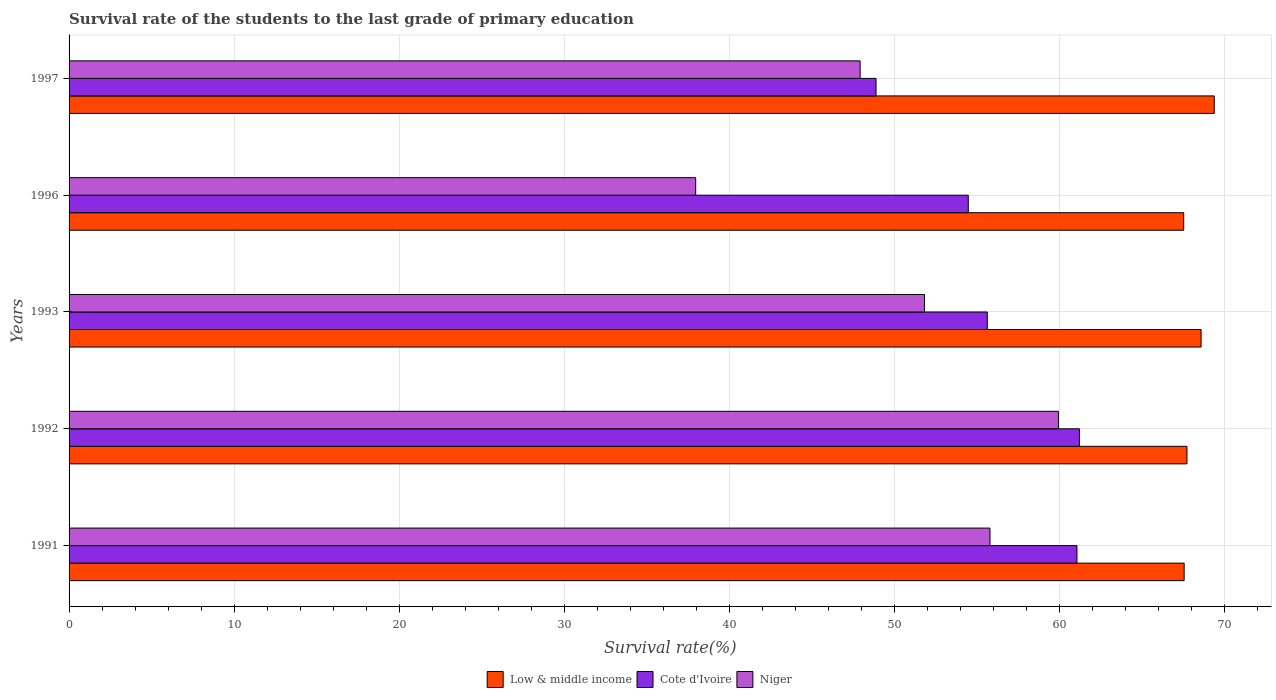How many groups of bars are there?
Ensure brevity in your answer.  5. Are the number of bars per tick equal to the number of legend labels?
Your answer should be very brief. Yes. Are the number of bars on each tick of the Y-axis equal?
Give a very brief answer. Yes. What is the label of the 1st group of bars from the top?
Offer a terse response. 1997. What is the survival rate of the students in Cote d'Ivoire in 1996?
Offer a very short reply. 54.46. Across all years, what is the maximum survival rate of the students in Low & middle income?
Provide a short and direct response. 69.36. Across all years, what is the minimum survival rate of the students in Low & middle income?
Your answer should be very brief. 67.51. In which year was the survival rate of the students in Cote d'Ivoire minimum?
Offer a terse response. 1997. What is the total survival rate of the students in Niger in the graph?
Make the answer very short. 253.36. What is the difference between the survival rate of the students in Low & middle income in 1992 and that in 1997?
Ensure brevity in your answer.  -1.65. What is the difference between the survival rate of the students in Niger in 1992 and the survival rate of the students in Cote d'Ivoire in 1997?
Offer a terse response. 11.05. What is the average survival rate of the students in Cote d'Ivoire per year?
Keep it short and to the point. 56.24. In the year 1997, what is the difference between the survival rate of the students in Niger and survival rate of the students in Low & middle income?
Your response must be concise. -21.45. What is the ratio of the survival rate of the students in Low & middle income in 1992 to that in 1996?
Offer a very short reply. 1. Is the survival rate of the students in Cote d'Ivoire in 1993 less than that in 1996?
Your response must be concise. No. What is the difference between the highest and the second highest survival rate of the students in Niger?
Your answer should be compact. 4.15. What is the difference between the highest and the lowest survival rate of the students in Low & middle income?
Make the answer very short. 1.85. Is the sum of the survival rate of the students in Low & middle income in 1991 and 1992 greater than the maximum survival rate of the students in Cote d'Ivoire across all years?
Your answer should be compact. Yes. What does the 1st bar from the top in 1997 represents?
Keep it short and to the point. Niger. What is the difference between two consecutive major ticks on the X-axis?
Ensure brevity in your answer.  10. Does the graph contain grids?
Offer a very short reply. Yes. What is the title of the graph?
Ensure brevity in your answer.  Survival rate of the students to the last grade of primary education. Does "Ethiopia" appear as one of the legend labels in the graph?
Provide a succinct answer. No. What is the label or title of the X-axis?
Provide a succinct answer. Survival rate(%). What is the Survival rate(%) in Low & middle income in 1991?
Offer a terse response. 67.53. What is the Survival rate(%) of Cote d'Ivoire in 1991?
Your response must be concise. 61.04. What is the Survival rate(%) in Niger in 1991?
Make the answer very short. 55.77. What is the Survival rate(%) in Low & middle income in 1992?
Offer a terse response. 67.7. What is the Survival rate(%) of Cote d'Ivoire in 1992?
Provide a succinct answer. 61.19. What is the Survival rate(%) in Niger in 1992?
Offer a terse response. 59.92. What is the Survival rate(%) in Low & middle income in 1993?
Your response must be concise. 68.56. What is the Survival rate(%) in Cote d'Ivoire in 1993?
Ensure brevity in your answer.  55.61. What is the Survival rate(%) in Niger in 1993?
Keep it short and to the point. 51.81. What is the Survival rate(%) in Low & middle income in 1996?
Offer a very short reply. 67.51. What is the Survival rate(%) of Cote d'Ivoire in 1996?
Make the answer very short. 54.46. What is the Survival rate(%) of Niger in 1996?
Provide a succinct answer. 37.95. What is the Survival rate(%) in Low & middle income in 1997?
Your answer should be very brief. 69.36. What is the Survival rate(%) of Cote d'Ivoire in 1997?
Give a very brief answer. 48.87. What is the Survival rate(%) in Niger in 1997?
Your response must be concise. 47.91. Across all years, what is the maximum Survival rate(%) of Low & middle income?
Your answer should be compact. 69.36. Across all years, what is the maximum Survival rate(%) of Cote d'Ivoire?
Provide a short and direct response. 61.19. Across all years, what is the maximum Survival rate(%) of Niger?
Your answer should be very brief. 59.92. Across all years, what is the minimum Survival rate(%) in Low & middle income?
Make the answer very short. 67.51. Across all years, what is the minimum Survival rate(%) of Cote d'Ivoire?
Your answer should be compact. 48.87. Across all years, what is the minimum Survival rate(%) in Niger?
Make the answer very short. 37.95. What is the total Survival rate(%) of Low & middle income in the graph?
Keep it short and to the point. 340.66. What is the total Survival rate(%) of Cote d'Ivoire in the graph?
Keep it short and to the point. 281.18. What is the total Survival rate(%) in Niger in the graph?
Make the answer very short. 253.36. What is the difference between the Survival rate(%) of Low & middle income in 1991 and that in 1992?
Ensure brevity in your answer.  -0.17. What is the difference between the Survival rate(%) of Cote d'Ivoire in 1991 and that in 1992?
Your answer should be very brief. -0.15. What is the difference between the Survival rate(%) in Niger in 1991 and that in 1992?
Keep it short and to the point. -4.15. What is the difference between the Survival rate(%) in Low & middle income in 1991 and that in 1993?
Offer a very short reply. -1.03. What is the difference between the Survival rate(%) of Cote d'Ivoire in 1991 and that in 1993?
Keep it short and to the point. 5.43. What is the difference between the Survival rate(%) in Niger in 1991 and that in 1993?
Make the answer very short. 3.97. What is the difference between the Survival rate(%) in Low & middle income in 1991 and that in 1996?
Ensure brevity in your answer.  0.03. What is the difference between the Survival rate(%) of Cote d'Ivoire in 1991 and that in 1996?
Make the answer very short. 6.58. What is the difference between the Survival rate(%) in Niger in 1991 and that in 1996?
Provide a succinct answer. 17.82. What is the difference between the Survival rate(%) of Low & middle income in 1991 and that in 1997?
Your answer should be very brief. -1.82. What is the difference between the Survival rate(%) of Cote d'Ivoire in 1991 and that in 1997?
Your response must be concise. 12.17. What is the difference between the Survival rate(%) of Niger in 1991 and that in 1997?
Ensure brevity in your answer.  7.86. What is the difference between the Survival rate(%) of Low & middle income in 1992 and that in 1993?
Ensure brevity in your answer.  -0.86. What is the difference between the Survival rate(%) of Cote d'Ivoire in 1992 and that in 1993?
Give a very brief answer. 5.58. What is the difference between the Survival rate(%) of Niger in 1992 and that in 1993?
Offer a terse response. 8.11. What is the difference between the Survival rate(%) of Low & middle income in 1992 and that in 1996?
Offer a terse response. 0.2. What is the difference between the Survival rate(%) in Cote d'Ivoire in 1992 and that in 1996?
Offer a very short reply. 6.73. What is the difference between the Survival rate(%) in Niger in 1992 and that in 1996?
Your response must be concise. 21.97. What is the difference between the Survival rate(%) of Low & middle income in 1992 and that in 1997?
Make the answer very short. -1.65. What is the difference between the Survival rate(%) in Cote d'Ivoire in 1992 and that in 1997?
Keep it short and to the point. 12.32. What is the difference between the Survival rate(%) in Niger in 1992 and that in 1997?
Ensure brevity in your answer.  12.01. What is the difference between the Survival rate(%) of Low & middle income in 1993 and that in 1996?
Provide a succinct answer. 1.05. What is the difference between the Survival rate(%) in Cote d'Ivoire in 1993 and that in 1996?
Make the answer very short. 1.15. What is the difference between the Survival rate(%) in Niger in 1993 and that in 1996?
Provide a short and direct response. 13.86. What is the difference between the Survival rate(%) in Low & middle income in 1993 and that in 1997?
Provide a succinct answer. -0.8. What is the difference between the Survival rate(%) of Cote d'Ivoire in 1993 and that in 1997?
Your answer should be compact. 6.74. What is the difference between the Survival rate(%) in Niger in 1993 and that in 1997?
Provide a succinct answer. 3.9. What is the difference between the Survival rate(%) in Low & middle income in 1996 and that in 1997?
Make the answer very short. -1.85. What is the difference between the Survival rate(%) in Cote d'Ivoire in 1996 and that in 1997?
Provide a short and direct response. 5.59. What is the difference between the Survival rate(%) in Niger in 1996 and that in 1997?
Provide a succinct answer. -9.96. What is the difference between the Survival rate(%) of Low & middle income in 1991 and the Survival rate(%) of Cote d'Ivoire in 1992?
Your answer should be compact. 6.34. What is the difference between the Survival rate(%) of Low & middle income in 1991 and the Survival rate(%) of Niger in 1992?
Make the answer very short. 7.61. What is the difference between the Survival rate(%) in Cote d'Ivoire in 1991 and the Survival rate(%) in Niger in 1992?
Your answer should be compact. 1.12. What is the difference between the Survival rate(%) in Low & middle income in 1991 and the Survival rate(%) in Cote d'Ivoire in 1993?
Ensure brevity in your answer.  11.92. What is the difference between the Survival rate(%) of Low & middle income in 1991 and the Survival rate(%) of Niger in 1993?
Your answer should be compact. 15.73. What is the difference between the Survival rate(%) of Cote d'Ivoire in 1991 and the Survival rate(%) of Niger in 1993?
Give a very brief answer. 9.24. What is the difference between the Survival rate(%) of Low & middle income in 1991 and the Survival rate(%) of Cote d'Ivoire in 1996?
Your answer should be very brief. 13.07. What is the difference between the Survival rate(%) in Low & middle income in 1991 and the Survival rate(%) in Niger in 1996?
Keep it short and to the point. 29.58. What is the difference between the Survival rate(%) of Cote d'Ivoire in 1991 and the Survival rate(%) of Niger in 1996?
Ensure brevity in your answer.  23.09. What is the difference between the Survival rate(%) in Low & middle income in 1991 and the Survival rate(%) in Cote d'Ivoire in 1997?
Provide a succinct answer. 18.66. What is the difference between the Survival rate(%) of Low & middle income in 1991 and the Survival rate(%) of Niger in 1997?
Ensure brevity in your answer.  19.62. What is the difference between the Survival rate(%) of Cote d'Ivoire in 1991 and the Survival rate(%) of Niger in 1997?
Your answer should be very brief. 13.13. What is the difference between the Survival rate(%) in Low & middle income in 1992 and the Survival rate(%) in Cote d'Ivoire in 1993?
Ensure brevity in your answer.  12.09. What is the difference between the Survival rate(%) of Low & middle income in 1992 and the Survival rate(%) of Niger in 1993?
Keep it short and to the point. 15.9. What is the difference between the Survival rate(%) in Cote d'Ivoire in 1992 and the Survival rate(%) in Niger in 1993?
Keep it short and to the point. 9.39. What is the difference between the Survival rate(%) of Low & middle income in 1992 and the Survival rate(%) of Cote d'Ivoire in 1996?
Your answer should be compact. 13.24. What is the difference between the Survival rate(%) of Low & middle income in 1992 and the Survival rate(%) of Niger in 1996?
Your answer should be very brief. 29.75. What is the difference between the Survival rate(%) in Cote d'Ivoire in 1992 and the Survival rate(%) in Niger in 1996?
Your response must be concise. 23.24. What is the difference between the Survival rate(%) of Low & middle income in 1992 and the Survival rate(%) of Cote d'Ivoire in 1997?
Offer a terse response. 18.83. What is the difference between the Survival rate(%) in Low & middle income in 1992 and the Survival rate(%) in Niger in 1997?
Offer a terse response. 19.79. What is the difference between the Survival rate(%) of Cote d'Ivoire in 1992 and the Survival rate(%) of Niger in 1997?
Ensure brevity in your answer.  13.28. What is the difference between the Survival rate(%) in Low & middle income in 1993 and the Survival rate(%) in Cote d'Ivoire in 1996?
Make the answer very short. 14.1. What is the difference between the Survival rate(%) of Low & middle income in 1993 and the Survival rate(%) of Niger in 1996?
Your answer should be compact. 30.61. What is the difference between the Survival rate(%) in Cote d'Ivoire in 1993 and the Survival rate(%) in Niger in 1996?
Give a very brief answer. 17.66. What is the difference between the Survival rate(%) of Low & middle income in 1993 and the Survival rate(%) of Cote d'Ivoire in 1997?
Ensure brevity in your answer.  19.69. What is the difference between the Survival rate(%) of Low & middle income in 1993 and the Survival rate(%) of Niger in 1997?
Make the answer very short. 20.65. What is the difference between the Survival rate(%) in Cote d'Ivoire in 1993 and the Survival rate(%) in Niger in 1997?
Your answer should be very brief. 7.7. What is the difference between the Survival rate(%) of Low & middle income in 1996 and the Survival rate(%) of Cote d'Ivoire in 1997?
Provide a short and direct response. 18.63. What is the difference between the Survival rate(%) of Low & middle income in 1996 and the Survival rate(%) of Niger in 1997?
Your answer should be compact. 19.6. What is the difference between the Survival rate(%) in Cote d'Ivoire in 1996 and the Survival rate(%) in Niger in 1997?
Offer a very short reply. 6.55. What is the average Survival rate(%) in Low & middle income per year?
Keep it short and to the point. 68.13. What is the average Survival rate(%) of Cote d'Ivoire per year?
Keep it short and to the point. 56.24. What is the average Survival rate(%) of Niger per year?
Keep it short and to the point. 50.67. In the year 1991, what is the difference between the Survival rate(%) in Low & middle income and Survival rate(%) in Cote d'Ivoire?
Provide a succinct answer. 6.49. In the year 1991, what is the difference between the Survival rate(%) of Low & middle income and Survival rate(%) of Niger?
Provide a short and direct response. 11.76. In the year 1991, what is the difference between the Survival rate(%) of Cote d'Ivoire and Survival rate(%) of Niger?
Your answer should be very brief. 5.27. In the year 1992, what is the difference between the Survival rate(%) in Low & middle income and Survival rate(%) in Cote d'Ivoire?
Make the answer very short. 6.51. In the year 1992, what is the difference between the Survival rate(%) of Low & middle income and Survival rate(%) of Niger?
Your response must be concise. 7.78. In the year 1992, what is the difference between the Survival rate(%) of Cote d'Ivoire and Survival rate(%) of Niger?
Give a very brief answer. 1.27. In the year 1993, what is the difference between the Survival rate(%) in Low & middle income and Survival rate(%) in Cote d'Ivoire?
Provide a short and direct response. 12.95. In the year 1993, what is the difference between the Survival rate(%) in Low & middle income and Survival rate(%) in Niger?
Provide a succinct answer. 16.75. In the year 1993, what is the difference between the Survival rate(%) of Cote d'Ivoire and Survival rate(%) of Niger?
Your answer should be compact. 3.81. In the year 1996, what is the difference between the Survival rate(%) of Low & middle income and Survival rate(%) of Cote d'Ivoire?
Offer a terse response. 13.05. In the year 1996, what is the difference between the Survival rate(%) in Low & middle income and Survival rate(%) in Niger?
Make the answer very short. 29.56. In the year 1996, what is the difference between the Survival rate(%) of Cote d'Ivoire and Survival rate(%) of Niger?
Keep it short and to the point. 16.51. In the year 1997, what is the difference between the Survival rate(%) in Low & middle income and Survival rate(%) in Cote d'Ivoire?
Give a very brief answer. 20.48. In the year 1997, what is the difference between the Survival rate(%) in Low & middle income and Survival rate(%) in Niger?
Provide a short and direct response. 21.45. In the year 1997, what is the difference between the Survival rate(%) in Cote d'Ivoire and Survival rate(%) in Niger?
Offer a very short reply. 0.96. What is the ratio of the Survival rate(%) of Niger in 1991 to that in 1992?
Your response must be concise. 0.93. What is the ratio of the Survival rate(%) of Cote d'Ivoire in 1991 to that in 1993?
Make the answer very short. 1.1. What is the ratio of the Survival rate(%) of Niger in 1991 to that in 1993?
Make the answer very short. 1.08. What is the ratio of the Survival rate(%) in Cote d'Ivoire in 1991 to that in 1996?
Your response must be concise. 1.12. What is the ratio of the Survival rate(%) of Niger in 1991 to that in 1996?
Your answer should be very brief. 1.47. What is the ratio of the Survival rate(%) of Low & middle income in 1991 to that in 1997?
Offer a terse response. 0.97. What is the ratio of the Survival rate(%) in Cote d'Ivoire in 1991 to that in 1997?
Your answer should be very brief. 1.25. What is the ratio of the Survival rate(%) of Niger in 1991 to that in 1997?
Offer a very short reply. 1.16. What is the ratio of the Survival rate(%) in Low & middle income in 1992 to that in 1993?
Give a very brief answer. 0.99. What is the ratio of the Survival rate(%) of Cote d'Ivoire in 1992 to that in 1993?
Offer a terse response. 1.1. What is the ratio of the Survival rate(%) of Niger in 1992 to that in 1993?
Give a very brief answer. 1.16. What is the ratio of the Survival rate(%) in Cote d'Ivoire in 1992 to that in 1996?
Make the answer very short. 1.12. What is the ratio of the Survival rate(%) of Niger in 1992 to that in 1996?
Offer a terse response. 1.58. What is the ratio of the Survival rate(%) of Low & middle income in 1992 to that in 1997?
Make the answer very short. 0.98. What is the ratio of the Survival rate(%) in Cote d'Ivoire in 1992 to that in 1997?
Provide a short and direct response. 1.25. What is the ratio of the Survival rate(%) of Niger in 1992 to that in 1997?
Provide a short and direct response. 1.25. What is the ratio of the Survival rate(%) in Low & middle income in 1993 to that in 1996?
Keep it short and to the point. 1.02. What is the ratio of the Survival rate(%) in Cote d'Ivoire in 1993 to that in 1996?
Offer a terse response. 1.02. What is the ratio of the Survival rate(%) in Niger in 1993 to that in 1996?
Give a very brief answer. 1.37. What is the ratio of the Survival rate(%) in Low & middle income in 1993 to that in 1997?
Provide a short and direct response. 0.99. What is the ratio of the Survival rate(%) of Cote d'Ivoire in 1993 to that in 1997?
Offer a terse response. 1.14. What is the ratio of the Survival rate(%) in Niger in 1993 to that in 1997?
Your answer should be very brief. 1.08. What is the ratio of the Survival rate(%) in Low & middle income in 1996 to that in 1997?
Your answer should be compact. 0.97. What is the ratio of the Survival rate(%) in Cote d'Ivoire in 1996 to that in 1997?
Your response must be concise. 1.11. What is the ratio of the Survival rate(%) in Niger in 1996 to that in 1997?
Your answer should be compact. 0.79. What is the difference between the highest and the second highest Survival rate(%) of Low & middle income?
Give a very brief answer. 0.8. What is the difference between the highest and the second highest Survival rate(%) in Cote d'Ivoire?
Offer a very short reply. 0.15. What is the difference between the highest and the second highest Survival rate(%) of Niger?
Your answer should be very brief. 4.15. What is the difference between the highest and the lowest Survival rate(%) of Low & middle income?
Provide a succinct answer. 1.85. What is the difference between the highest and the lowest Survival rate(%) of Cote d'Ivoire?
Your answer should be compact. 12.32. What is the difference between the highest and the lowest Survival rate(%) in Niger?
Your answer should be very brief. 21.97. 